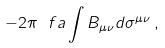Convert formula to latex. <formula><loc_0><loc_0><loc_500><loc_500>- 2 \pi \ f a \int B _ { \mu \nu } d \sigma ^ { \mu \nu } \, ,</formula> 